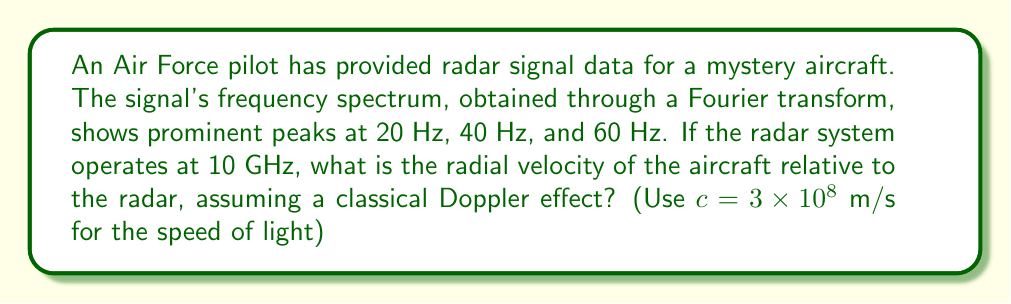Provide a solution to this math problem. To solve this problem, we'll use the Doppler effect formula for radar systems. The Fourier transform of the radar signal reveals the frequency shifts caused by the moving aircraft.

1) The Doppler shift formula for radar is:

   $$f_d = \frac{2v_r}{c}f_0$$

   Where:
   $f_d$ is the Doppler shift frequency
   $v_r$ is the radial velocity of the target
   $c$ is the speed of light
   $f_0$ is the radar's operating frequency

2) We observe peaks at 20 Hz, 40 Hz, and 60 Hz. These are harmonics of the fundamental Doppler shift frequency, which is 20 Hz.

3) Therefore, $f_d = 20$ Hz

4) We know $f_0 = 10$ GHz $= 10 \times 10^9$ Hz and $c = 3 \times 10^8$ m/s

5) Substituting into the formula:

   $$20 = \frac{2v_r}{3 \times 10^8} \times 10 \times 10^9$$

6) Solving for $v_r$:

   $$v_r = \frac{20 \times 3 \times 10^8}{2 \times 10 \times 10^9} = 300 \text{ m/s}$$

Thus, the radial velocity of the aircraft relative to the radar is 300 m/s.
Answer: 300 m/s 